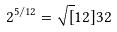<formula> <loc_0><loc_0><loc_500><loc_500>2 ^ { 5 / 1 2 } = \sqrt { [ } 1 2 ] { 3 2 }</formula> 